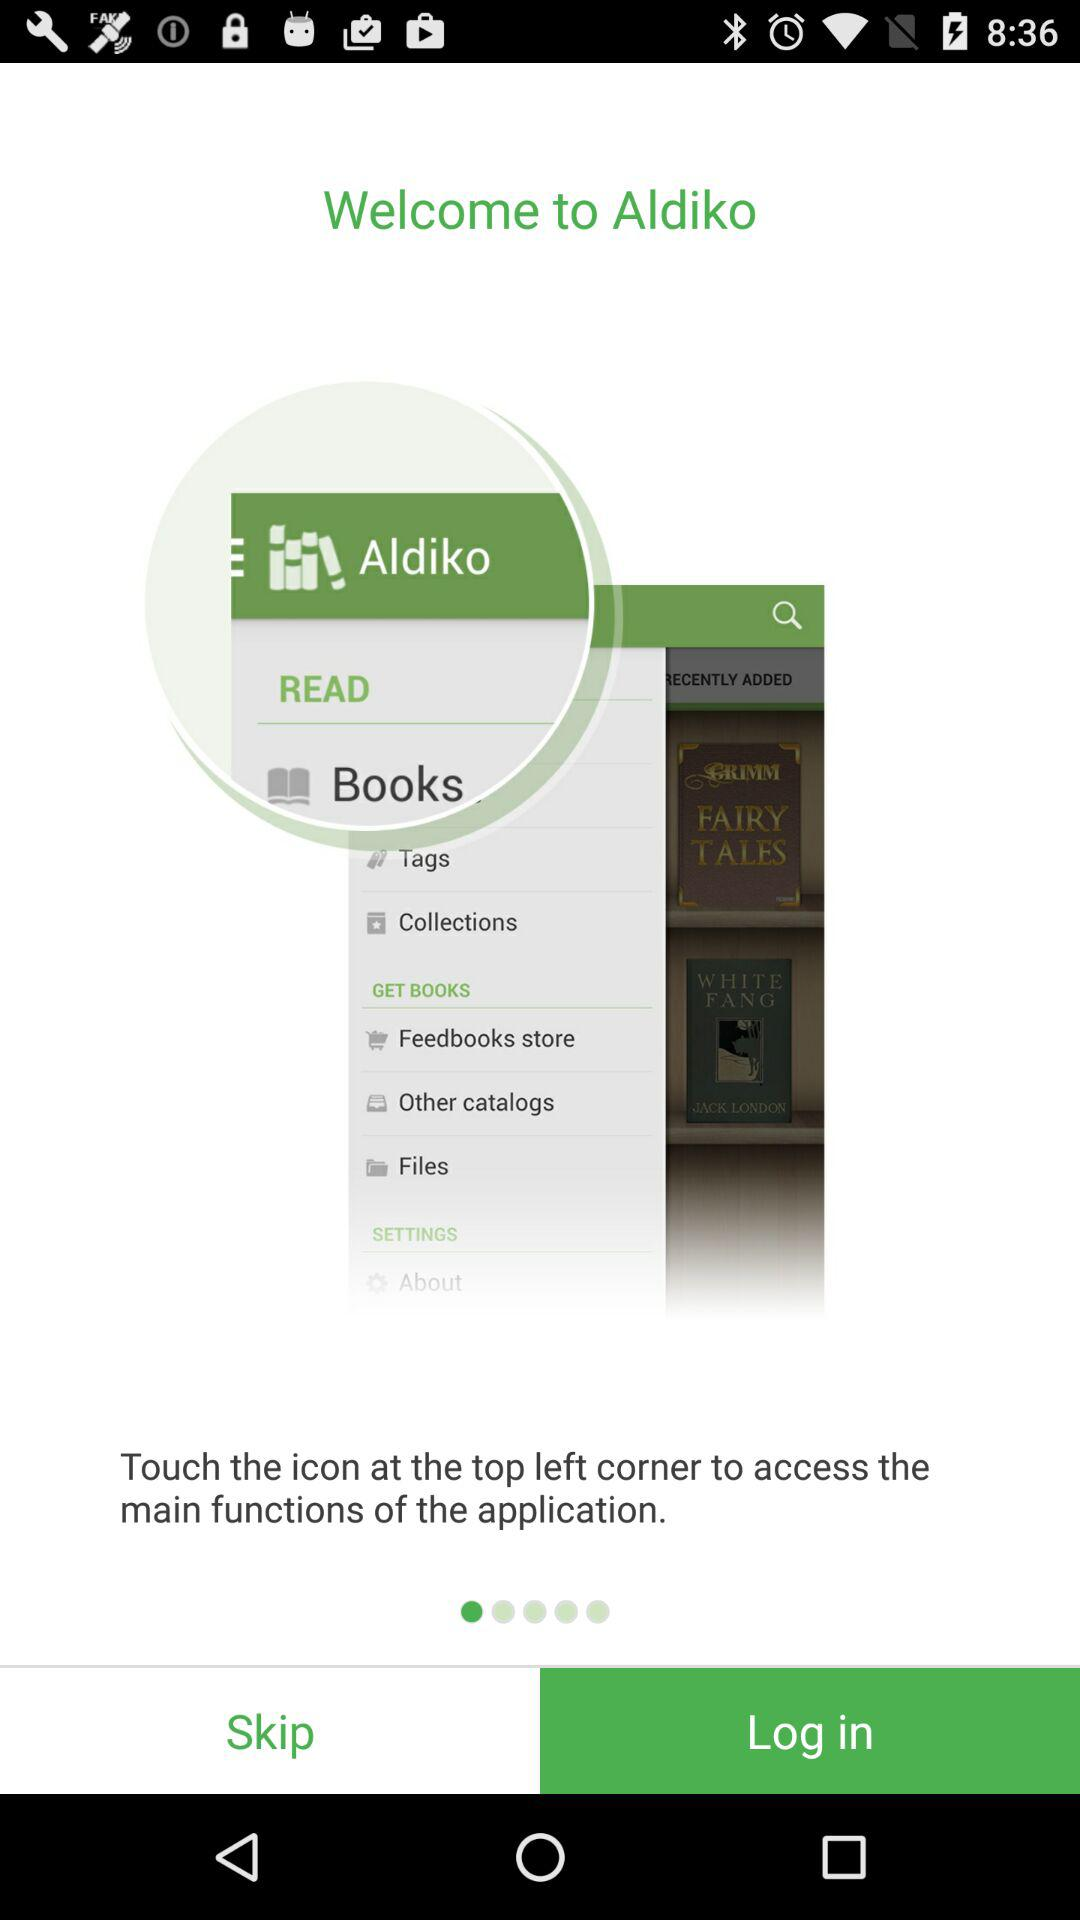What is the app name? The app name is "Aldiko". 